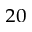<formula> <loc_0><loc_0><loc_500><loc_500>_ { 2 0 }</formula> 